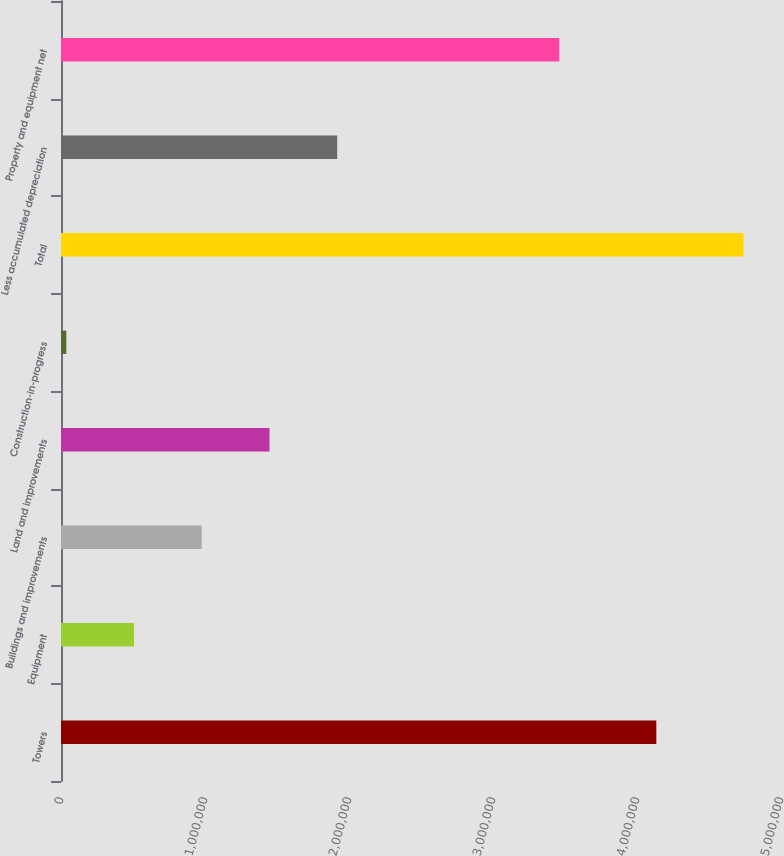Convert chart to OTSL. <chart><loc_0><loc_0><loc_500><loc_500><bar_chart><fcel>Towers<fcel>Equipment<fcel>Buildings and improvements<fcel>Land and improvements<fcel>Construction-in-progress<fcel>Total<fcel>Less accumulated depreciation<fcel>Property and equipment net<nl><fcel>4.13416e+06<fcel>507249<fcel>977508<fcel>1.44777e+06<fcel>36991<fcel>4.73958e+06<fcel>1.91802e+06<fcel>3.46053e+06<nl></chart> 